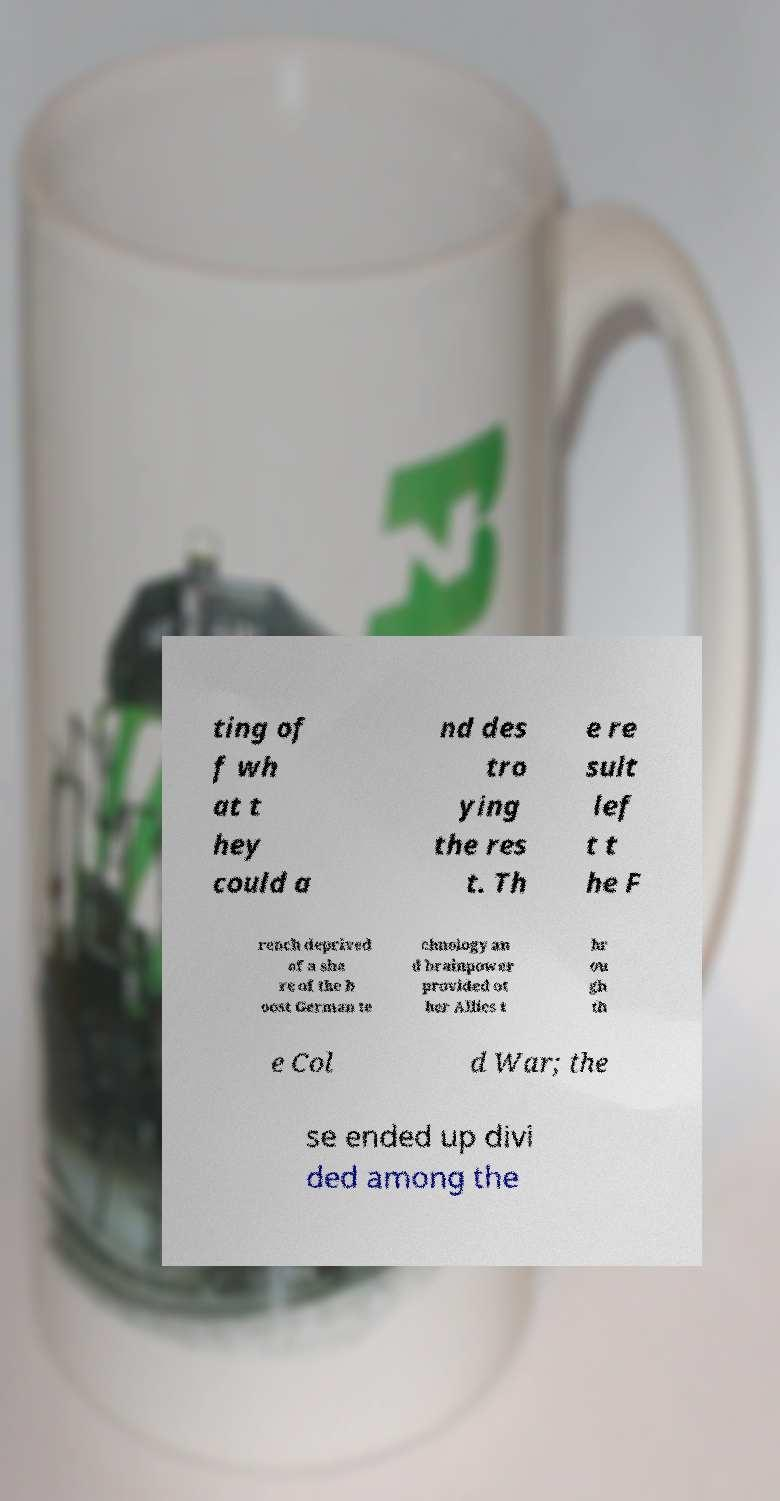There's text embedded in this image that I need extracted. Can you transcribe it verbatim? ting of f wh at t hey could a nd des tro ying the res t. Th e re sult lef t t he F rench deprived of a sha re of the b oost German te chnology an d brainpower provided ot her Allies t hr ou gh th e Col d War; the se ended up divi ded among the 